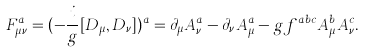Convert formula to latex. <formula><loc_0><loc_0><loc_500><loc_500>F _ { \mu \nu } ^ { a } = ( - { \frac { i } { g } } [ D _ { \mu } , D _ { \nu } ] ) ^ { a } = \partial _ { \mu } A _ { \nu } ^ { a } - \partial _ { \nu } A _ { \mu } ^ { a } - g f ^ { a b c } A _ { \mu } ^ { b } A _ { \nu } ^ { c } .</formula> 